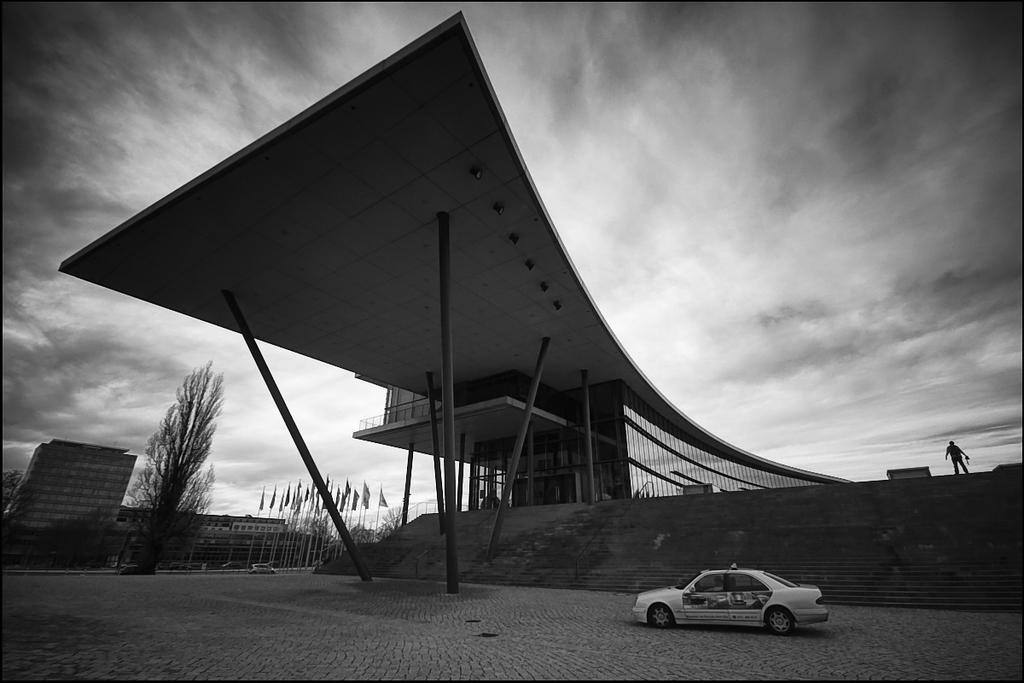What type of structures can be seen in the image? There are buildings in the image. What other elements are present in the image besides buildings? There are trees, flags, poles, and vehicles in the image. What is the color scheme of the image? The image is in black and white. What type of stitch is used to create the flags in the image? There is no information about the type of stitch used to create the flags in the image, as the focus is on the presence of flags and not their construction. 